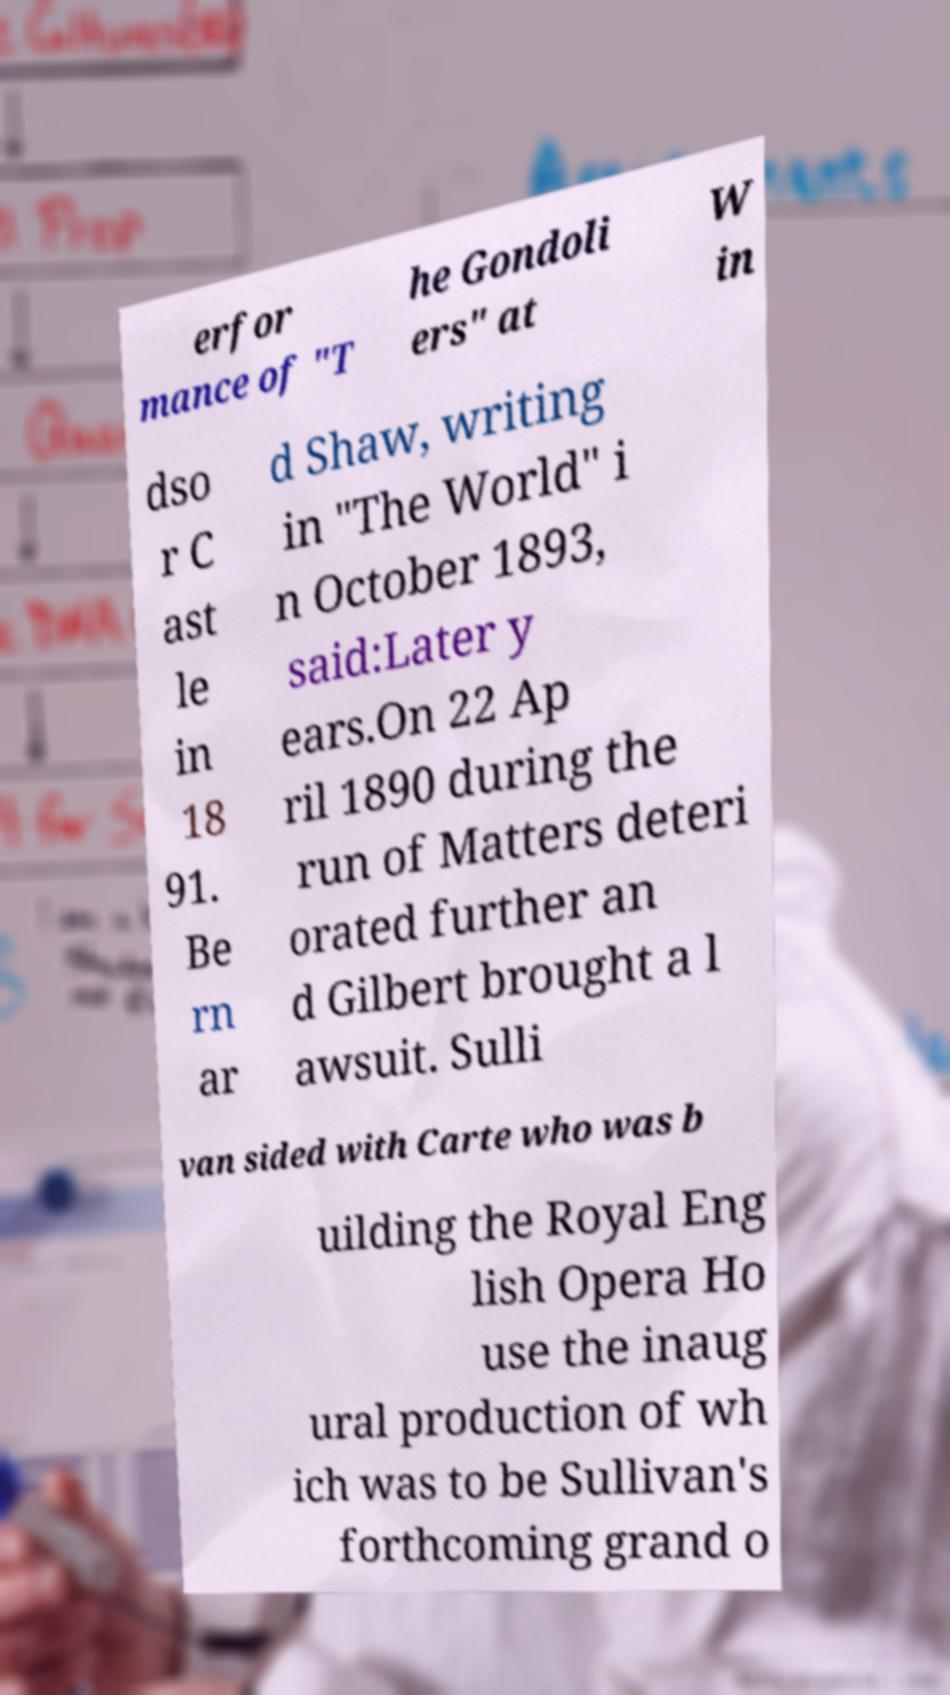For documentation purposes, I need the text within this image transcribed. Could you provide that? erfor mance of "T he Gondoli ers" at W in dso r C ast le in 18 91. Be rn ar d Shaw, writing in "The World" i n October 1893, said:Later y ears.On 22 Ap ril 1890 during the run of Matters deteri orated further an d Gilbert brought a l awsuit. Sulli van sided with Carte who was b uilding the Royal Eng lish Opera Ho use the inaug ural production of wh ich was to be Sullivan's forthcoming grand o 